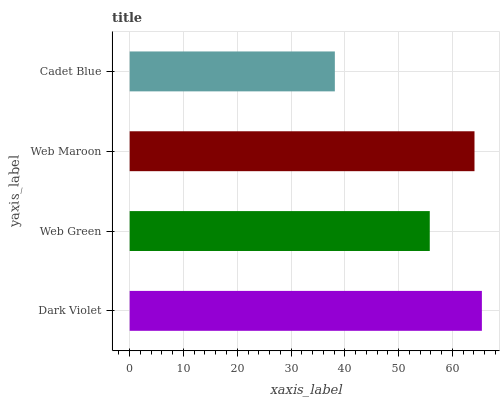Is Cadet Blue the minimum?
Answer yes or no. Yes. Is Dark Violet the maximum?
Answer yes or no. Yes. Is Web Green the minimum?
Answer yes or no. No. Is Web Green the maximum?
Answer yes or no. No. Is Dark Violet greater than Web Green?
Answer yes or no. Yes. Is Web Green less than Dark Violet?
Answer yes or no. Yes. Is Web Green greater than Dark Violet?
Answer yes or no. No. Is Dark Violet less than Web Green?
Answer yes or no. No. Is Web Maroon the high median?
Answer yes or no. Yes. Is Web Green the low median?
Answer yes or no. Yes. Is Cadet Blue the high median?
Answer yes or no. No. Is Web Maroon the low median?
Answer yes or no. No. 